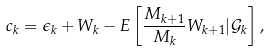<formula> <loc_0><loc_0><loc_500><loc_500>c _ { k } = \epsilon _ { k } + W _ { k } - E \left [ \frac { M _ { k + 1 } } { M _ { k } } W _ { k + 1 } | \mathcal { G } _ { k } \right ] ,</formula> 